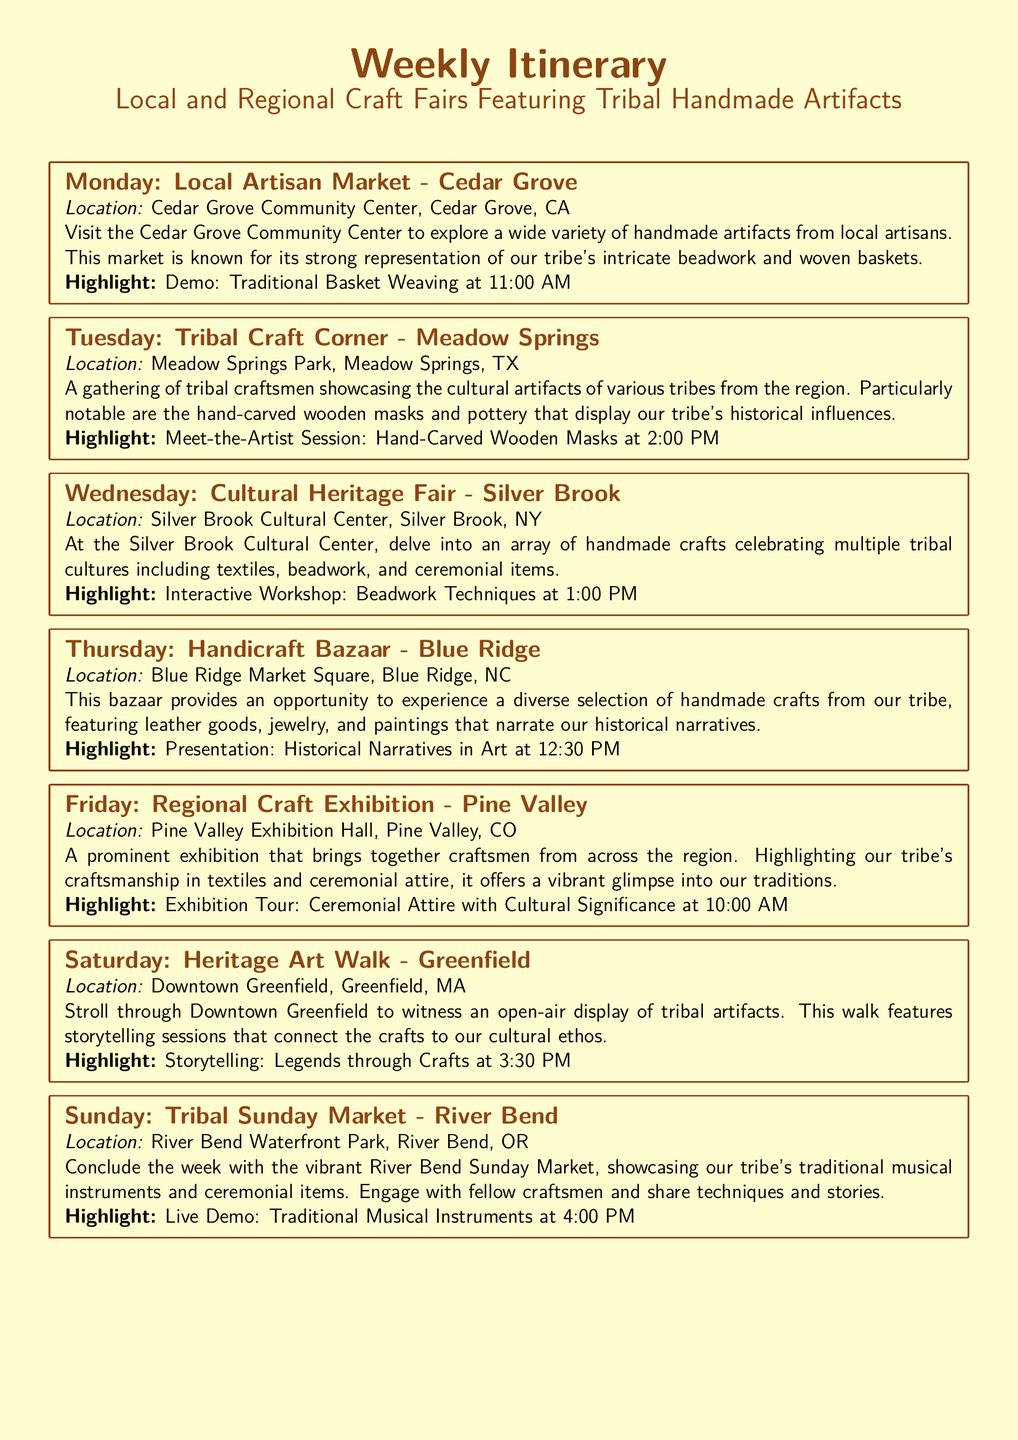What is the location of the Local Artisan Market? The location of the Local Artisan Market is Cedar Grove Community Center, Cedar Grove, CA.
Answer: Cedar Grove Community Center, Cedar Grove, CA What is featured at the Tribal Craft Corner? The Tribal Craft Corner features hand-carved wooden masks and pottery.
Answer: Hand-carved wooden masks and pottery What time is the interactive workshop at the Cultural Heritage Fair? The interactive workshop begins at 1:00 PM at the Cultural Heritage Fair.
Answer: 1:00 PM Which day features a storytelling session? A storytelling session takes place on Saturday during the Heritage Art Walk.
Answer: Saturday What type of artifacts are showcased at the Tribal Sunday Market? The Tribal Sunday Market showcases traditional musical instruments and ceremonial items.
Answer: Traditional musical instruments and ceremonial items Which event occurs in Blue Ridge? The event that occurs in Blue Ridge is the Handicraft Bazaar.
Answer: Handicraft Bazaar What is the highlight of the Regional Craft Exhibition? The highlight of the Regional Craft Exhibition is the Exhibition Tour: Ceremonial Attire with Cultural Significance.
Answer: Exhibition Tour: Ceremonial Attire with Cultural Significance What type of crafts is emphasized at the Cedar Grove Community Center? The type of crafts emphasized at the Cedar Grove Community Center is intricate beadwork and woven baskets.
Answer: Intricate beadwork and woven baskets On which day do craftsmen share techniques and stories? Craftsmen share techniques and stories on Sunday at the Tribal Sunday Market.
Answer: Sunday 